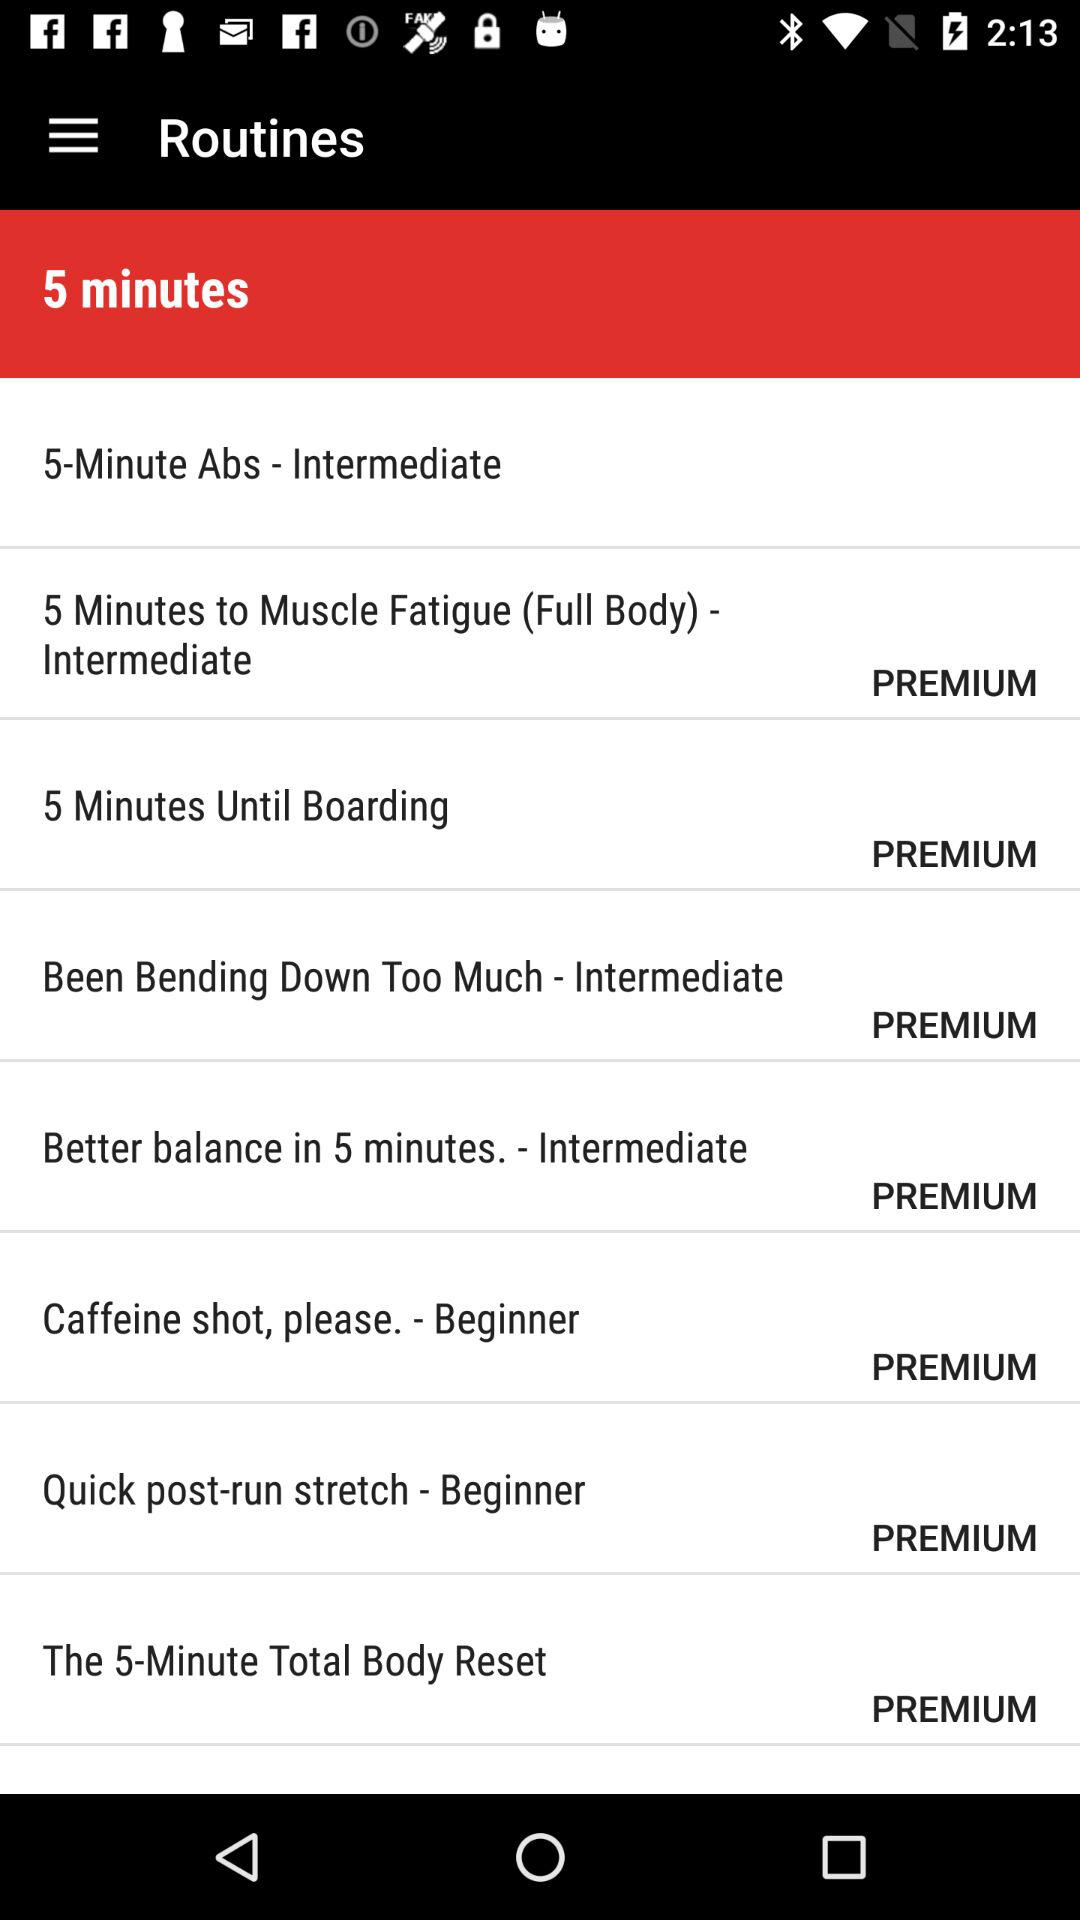How many routines are there in the 5 minutes category?
Answer the question using a single word or phrase. 8 